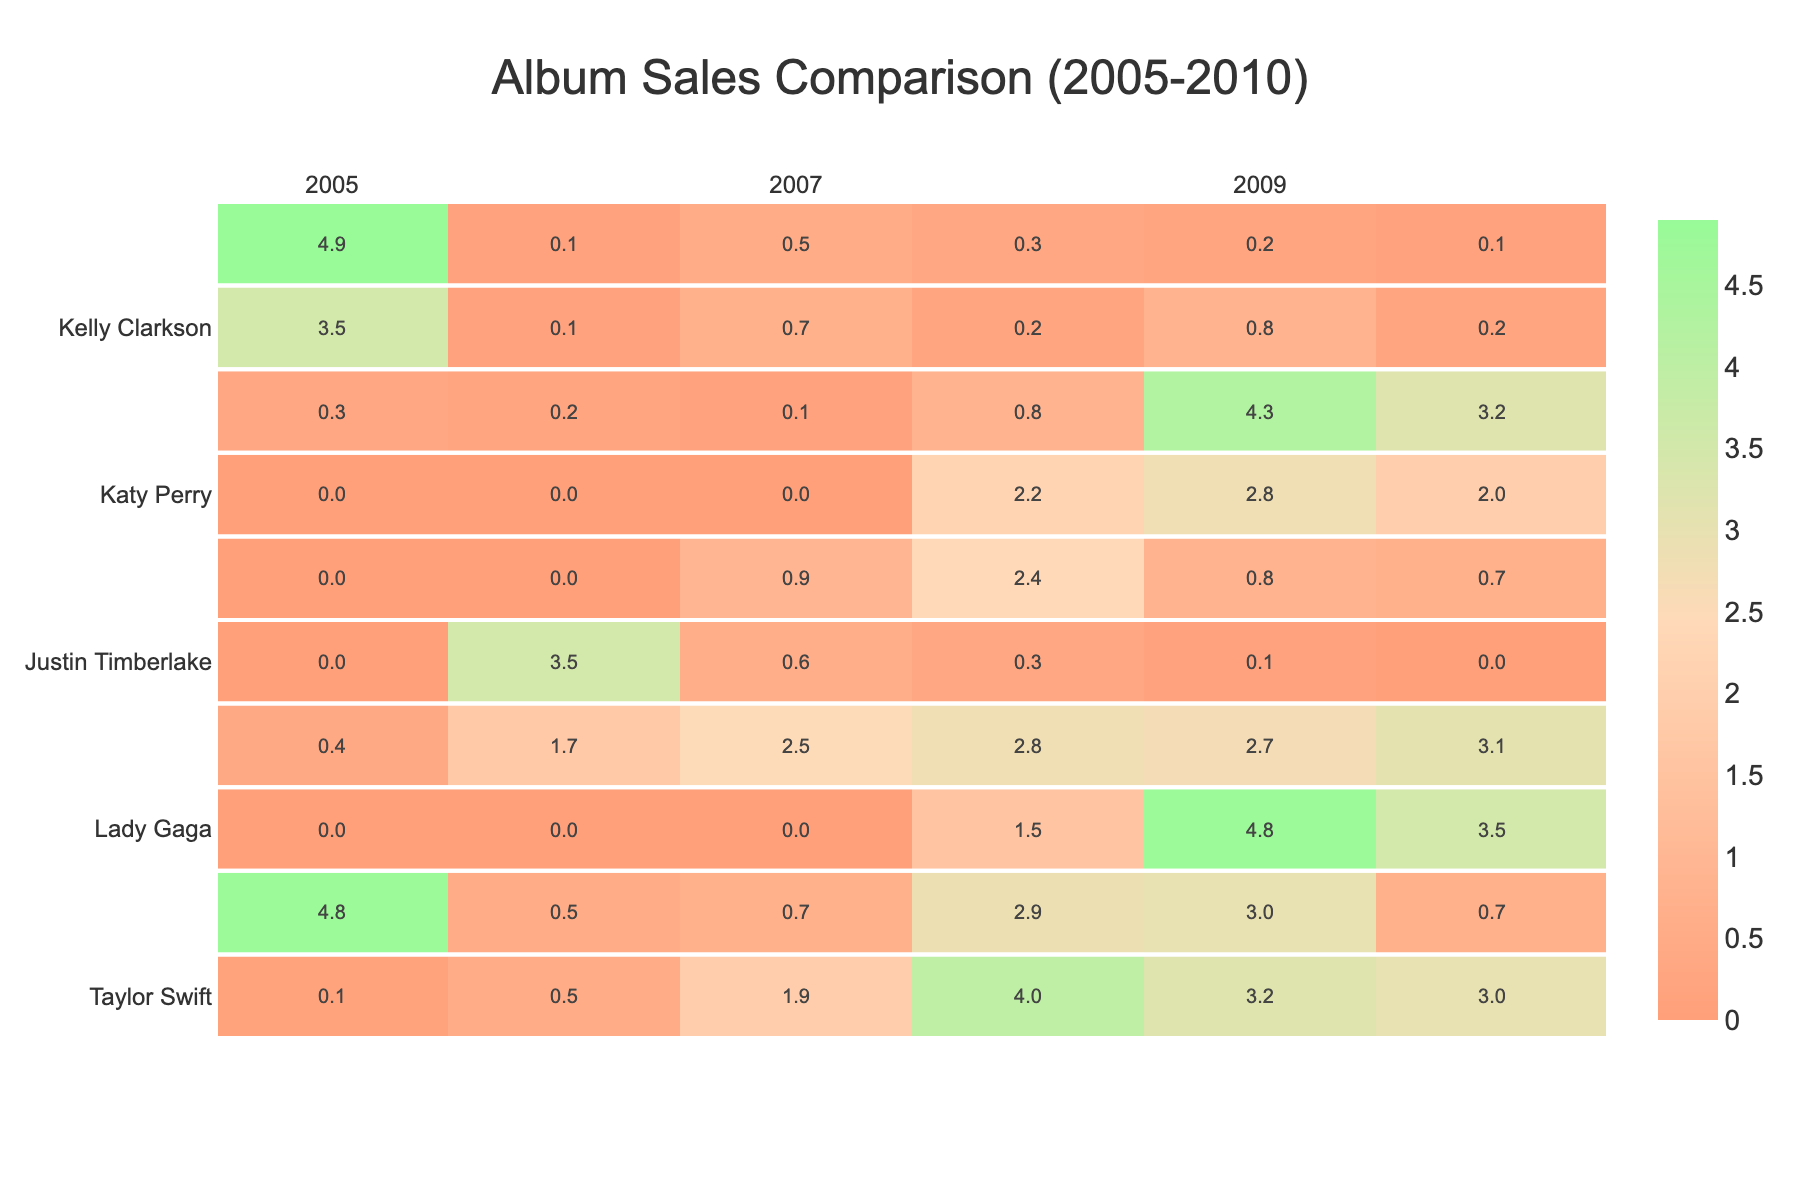What's the highest album sales number for Taylor Swift? Referring to the table, Taylor Swift's highest album sales occurred in 2008 with 4.0 million units sold.
Answer: 4.0 million Which year did Lady Gaga achieve the highest sales? Looking at the table, Lady Gaga's highest sales occurred in 2009 with 4.8 million units sold.
Answer: 4.8 million How many years did Rihanna's album sales exceed 2 million? Analyzing Rihanna's sales numbers, she exceeded 2 million in 2007, 2008, and 2009, which counts to three years.
Answer: 3 years What is the total album sales for Beyoncé from 2005 to 2010? Summing Beyoncé's album sales across all years: 4.8 + 0.5 + 0.7 + 2.9 + 3.0 + 0.7 = 12.6 million units.
Answer: 12.6 million Did Mariah Carey sell more albums than Kelly Clarkson in 2006? In 2006, Mariah Carey sold 0.1 million while Kelly Clarkson sold 0.1 million, making it a tie.
Answer: No Which artist had the lowest sales in 2010? The lowest sales in 2010 were by Mariah Carey, with only 0.1 million units sold.
Answer: Mariah Carey What was the average album sales for Katy Perry across the years? Adding Katy Perry's sales: 0 + 0 + 0 + 2.2 + 2.8 + 2.0 = 5.0 million; dividing by 6 gives an average of 5.0 / 6 ≈ 0.833 million units.
Answer: 0.833 million How many artists had sales above 3 million in any year? Checking the table, Taylor Swift (2008), Rihanna (2009, 2010), and Lady Gaga (2009) had sales above 3 million, totaling four instances among three artists.
Answer: 3 artists What were the trends in Justin Timberlake's album sales from 2005 to 2010? Justin Timberlake's sales declined from 3.5 million in 2006 to 0 in 2010 after a peak in 2006, indicating a downtrend overall.
Answer: Downtrend In which year did the Black Eyed Peas experience their highest album sales? The Black Eyed Peas' highest album sales were observed in 2009 with 4.3 million units sold.
Answer: 4.3 million 